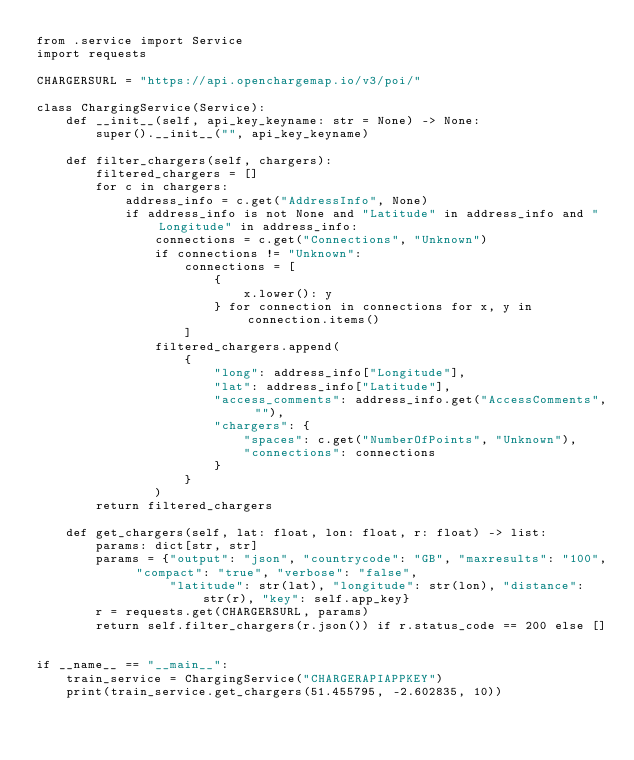<code> <loc_0><loc_0><loc_500><loc_500><_Python_>from .service import Service
import requests

CHARGERSURL = "https://api.openchargemap.io/v3/poi/"

class ChargingService(Service):
    def __init__(self, api_key_keyname: str = None) -> None:
        super().__init__("", api_key_keyname)

    def filter_chargers(self, chargers):
        filtered_chargers = []
        for c in chargers:
            address_info = c.get("AddressInfo", None)
            if address_info is not None and "Latitude" in address_info and "Longitude" in address_info:
                connections = c.get("Connections", "Unknown")
                if connections != "Unknown":
                    connections = [
                        {
                            x.lower(): y
                        } for connection in connections for x, y in connection.items()
                    ]
                filtered_chargers.append(
                    {
                        "long": address_info["Longitude"],
                        "lat": address_info["Latitude"],
                        "access_comments": address_info.get("AccessComments", ""),
                        "chargers": {
                            "spaces": c.get("NumberOfPoints", "Unknown"),
                            "connections": connections
                        }
                    }
                )
        return filtered_chargers

    def get_chargers(self, lat: float, lon: float, r: float) -> list:
        params: dict[str, str]
        params = {"output": "json", "countrycode": "GB", "maxresults": "100", "compact": "true", "verbose": "false",
                  "latitude": str(lat), "longitude": str(lon), "distance": str(r), "key": self.app_key}
        r = requests.get(CHARGERSURL, params)
        return self.filter_chargers(r.json()) if r.status_code == 200 else []


if __name__ == "__main__":
    train_service = ChargingService("CHARGERAPIAPPKEY")
    print(train_service.get_chargers(51.455795, -2.602835, 10))
</code> 